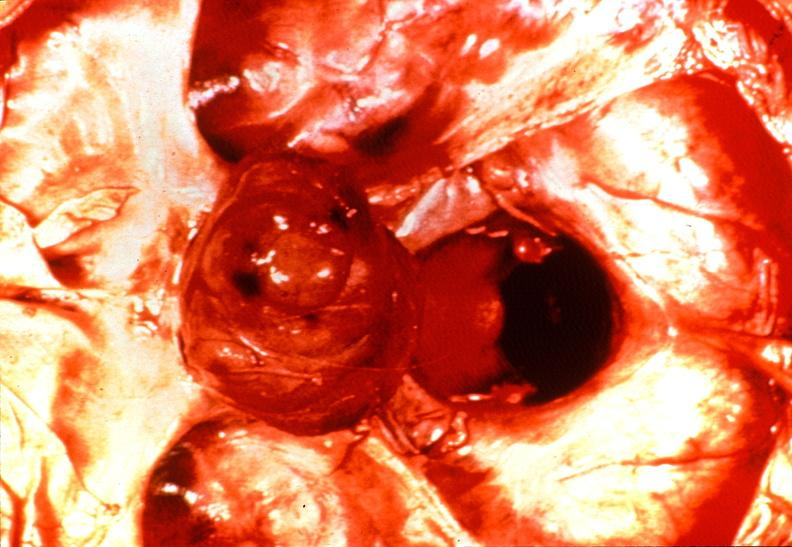what does this image show?
Answer the question using a single word or phrase. Pituitary 